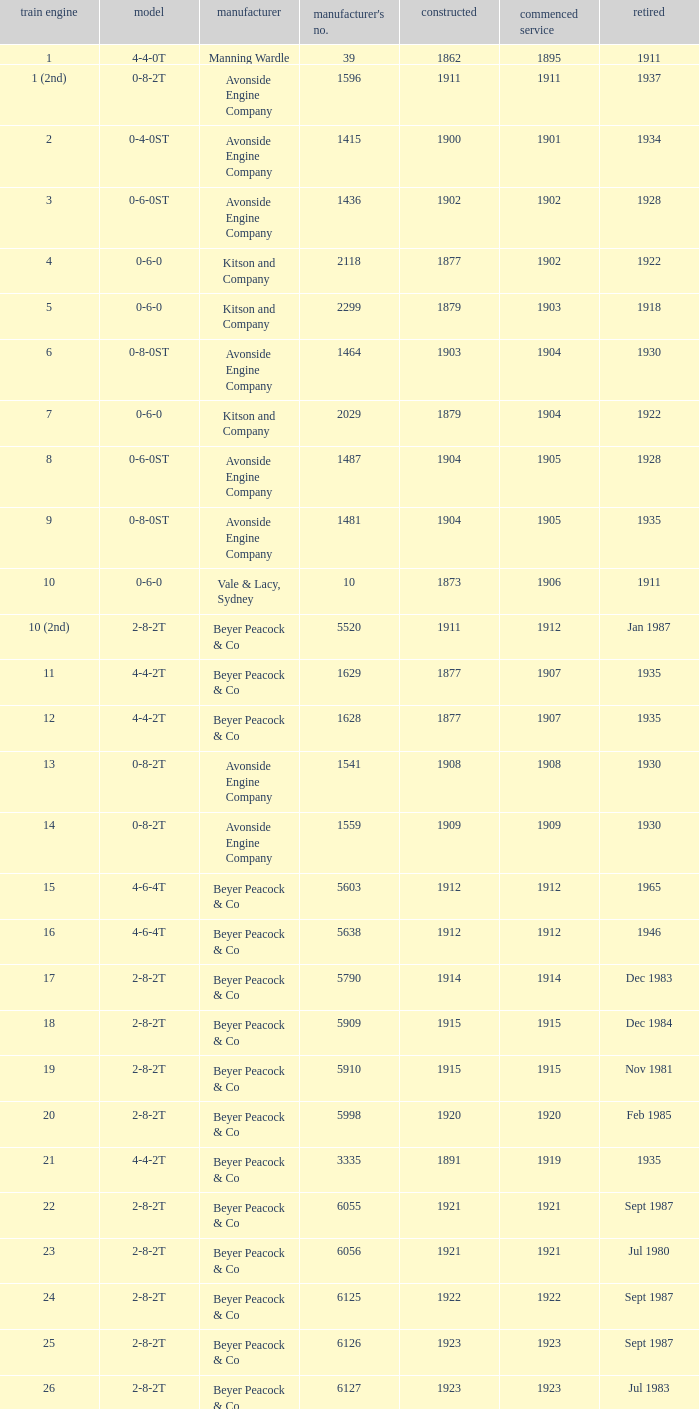Which locomotive had a 2-8-2t type, entered service year prior to 1915, and which was built after 1911? 17.0. 